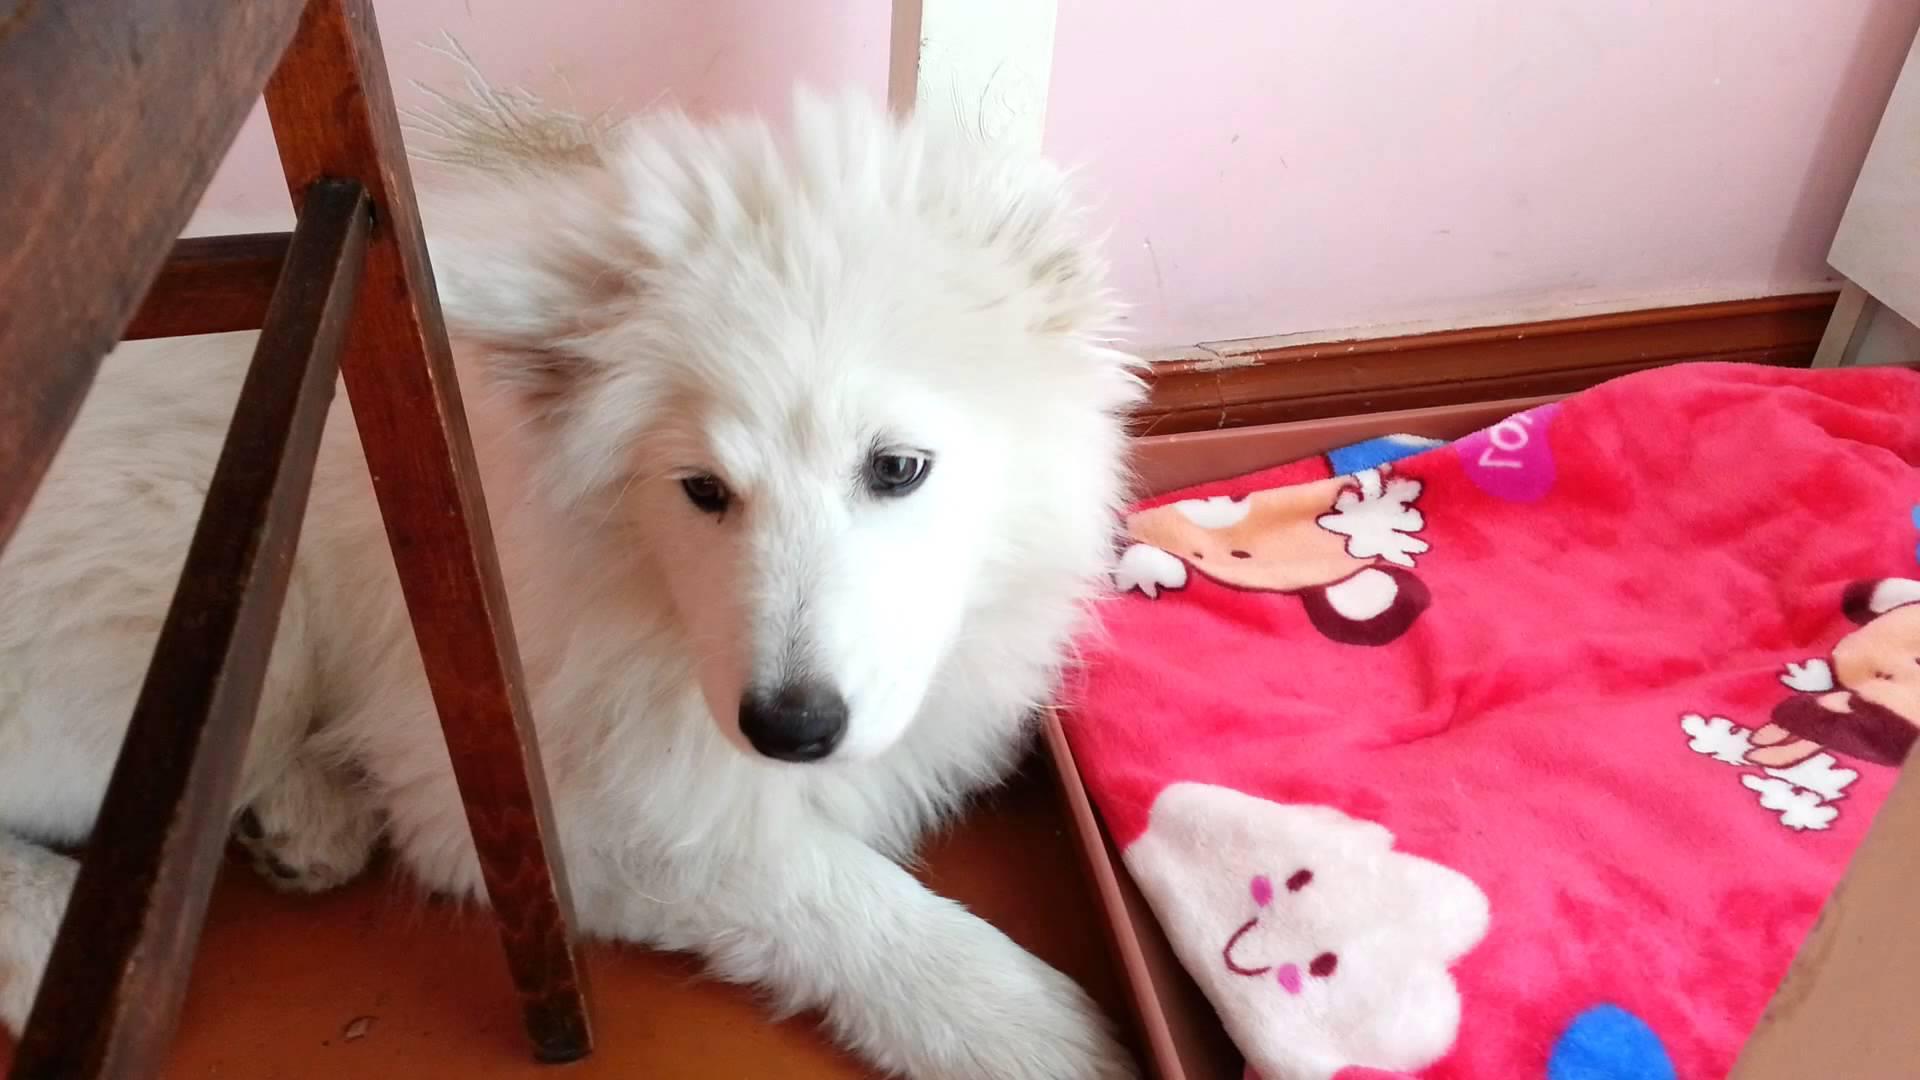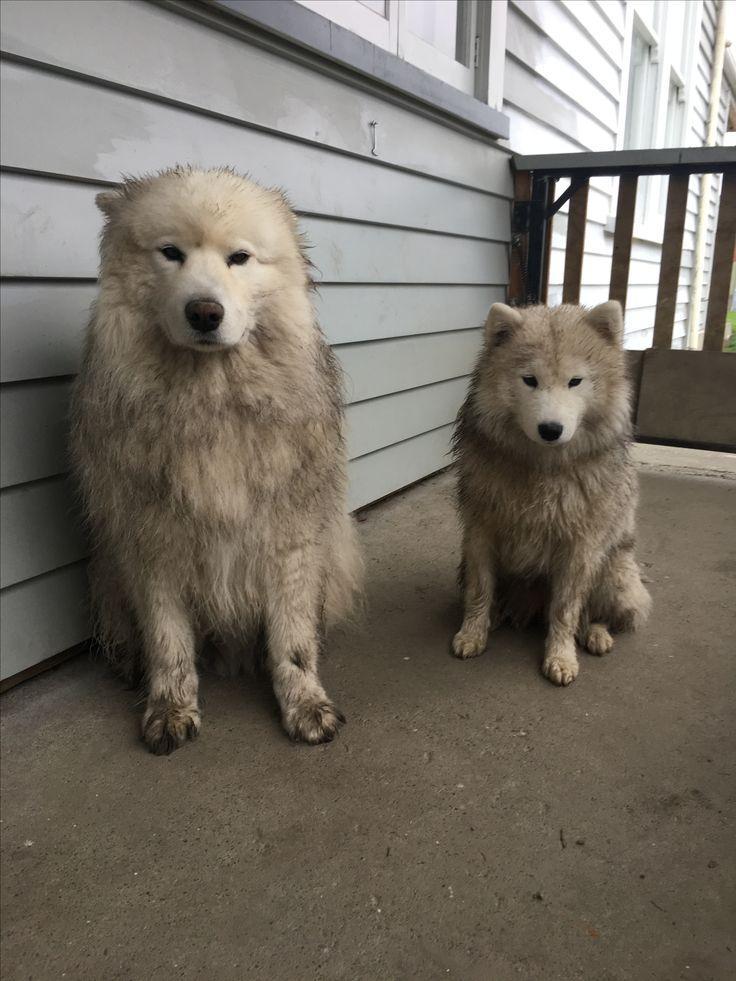The first image is the image on the left, the second image is the image on the right. Examine the images to the left and right. Is the description "There are at least 2 dogs." accurate? Answer yes or no. Yes. The first image is the image on the left, the second image is the image on the right. Assess this claim about the two images: "There are three dogs.". Correct or not? Answer yes or no. Yes. 